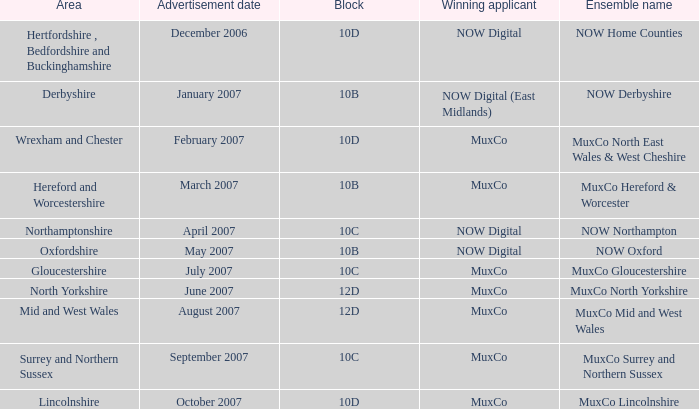Who is the Winning Applicant of Ensemble Name Muxco Lincolnshire in Block 10D? MuxCo. 